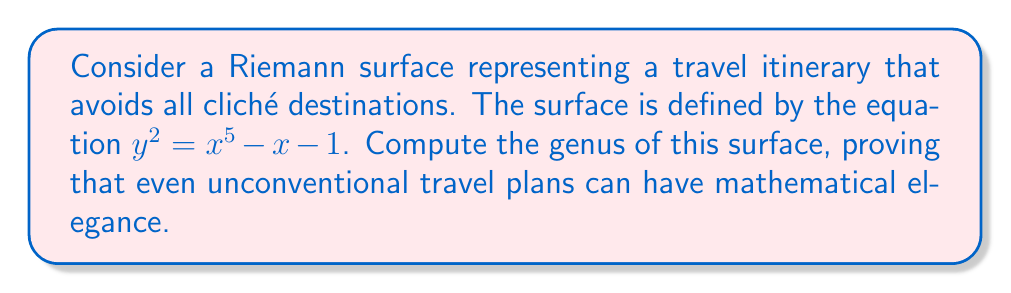Give your solution to this math problem. To compute the genus of the Riemann surface, we'll follow these steps:

1) The genus of a Riemann surface defined by an equation of the form $y^2 = f(x)$, where $f(x)$ is a polynomial, is given by the formula:

   $$g = \frac{d-1}{2}$$

   where $d$ is the degree of $f(x)$.

2) In our case, $f(x) = x^5 - x - 1$. The degree of this polynomial is 5.

3) Substituting into the formula:

   $$g = \frac{5-1}{2} = \frac{4}{2} = 2$$

4) To verify, we can use the Riemann-Hurwitz formula. The surface is a double cover of the complex plane, branched at the roots of $f(x)$ and at infinity. The number of branch points is 6 (5 roots plus infinity).

5) The Riemann-Hurwitz formula states:

   $$2g - 2 = 2(-2) + 6$$

   where -2 is the Euler characteristic of the complex plane.

6) Solving this equation:

   $$2g - 2 = -4 + 6 = 2$$
   $$2g = 4$$
   $$g = 2$$

This confirms our initial calculation.
Answer: 2 